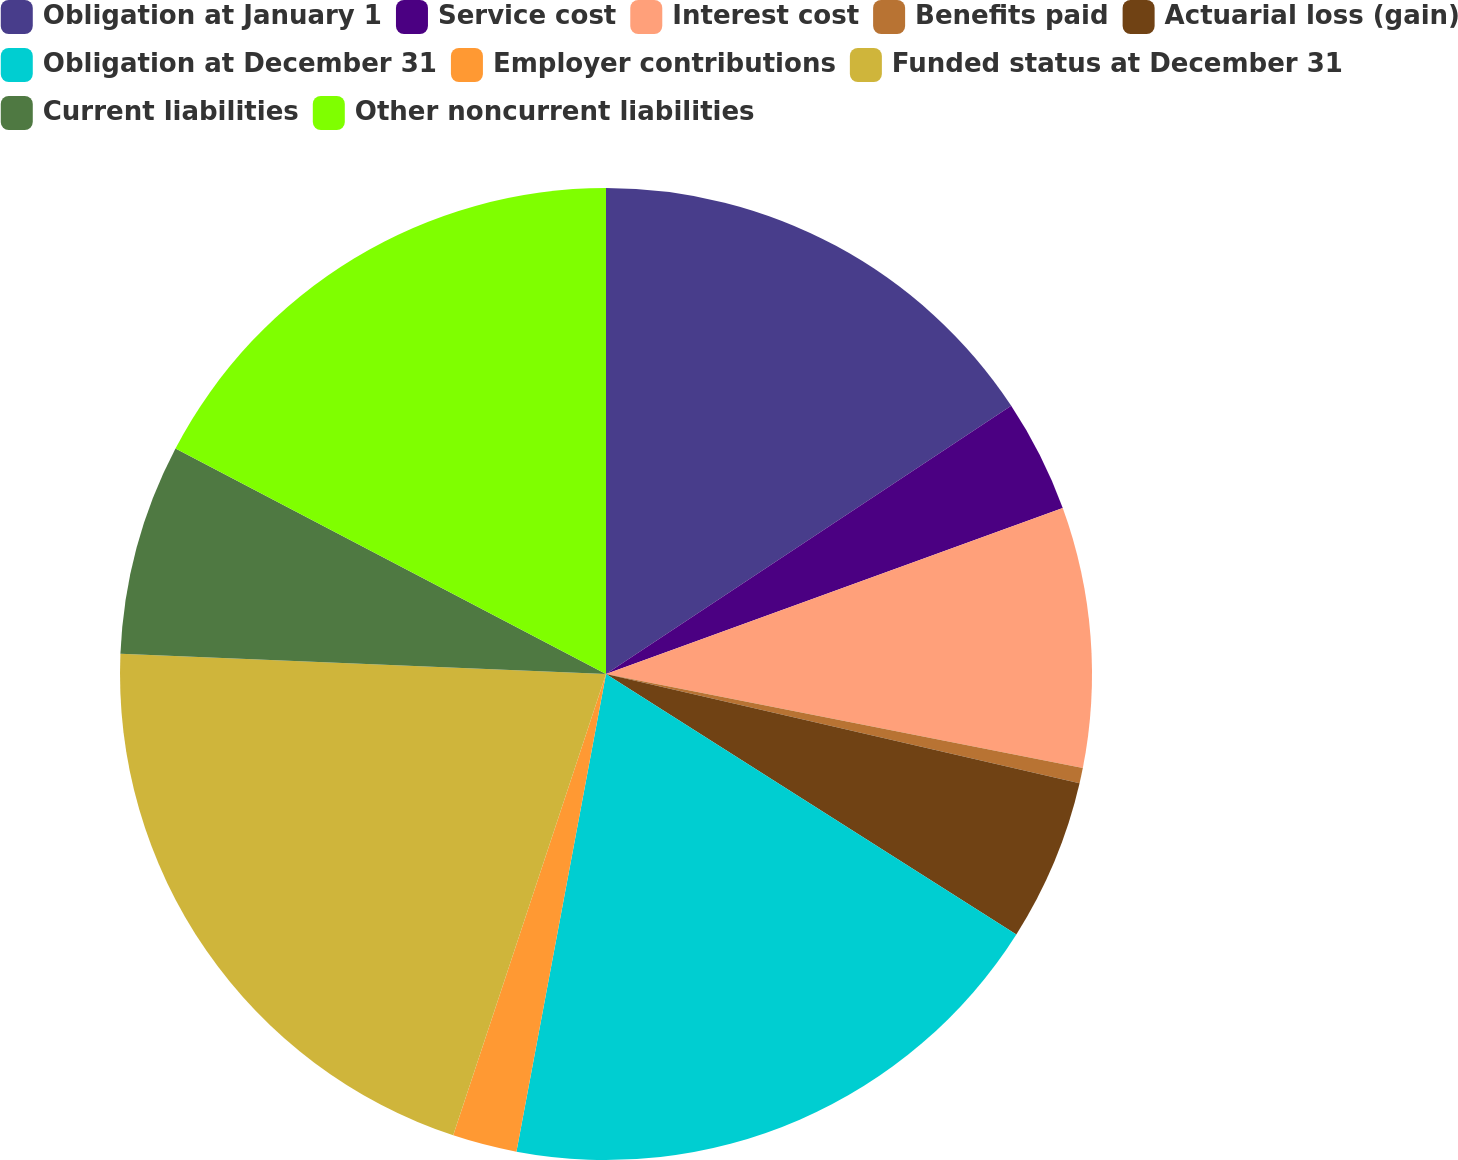Convert chart. <chart><loc_0><loc_0><loc_500><loc_500><pie_chart><fcel>Obligation at January 1<fcel>Service cost<fcel>Interest cost<fcel>Benefits paid<fcel>Actuarial loss (gain)<fcel>Obligation at December 31<fcel>Employer contributions<fcel>Funded status at December 31<fcel>Current liabilities<fcel>Other noncurrent liabilities<nl><fcel>15.69%<fcel>3.76%<fcel>8.65%<fcel>0.51%<fcel>5.39%<fcel>18.95%<fcel>2.14%<fcel>20.57%<fcel>7.02%<fcel>17.32%<nl></chart> 